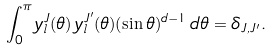<formula> <loc_0><loc_0><loc_500><loc_500>\int _ { 0 } ^ { \pi } y ^ { J } _ { l } ( \theta ) \, y ^ { J ^ { \prime } } _ { l } ( \theta ) ( \sin \theta ) ^ { d - 1 } \, d \theta = \delta _ { J , J ^ { \prime } } .</formula> 